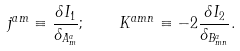<formula> <loc_0><loc_0><loc_500><loc_500>j ^ { a m } \equiv \frac { \delta I _ { 1 } } { \delta _ { A _ { m } ^ { a } } } ; \quad K ^ { a m n } \equiv - 2 \frac { \delta I _ { 2 } } { \delta _ { B _ { m n } ^ { a } } } .</formula> 